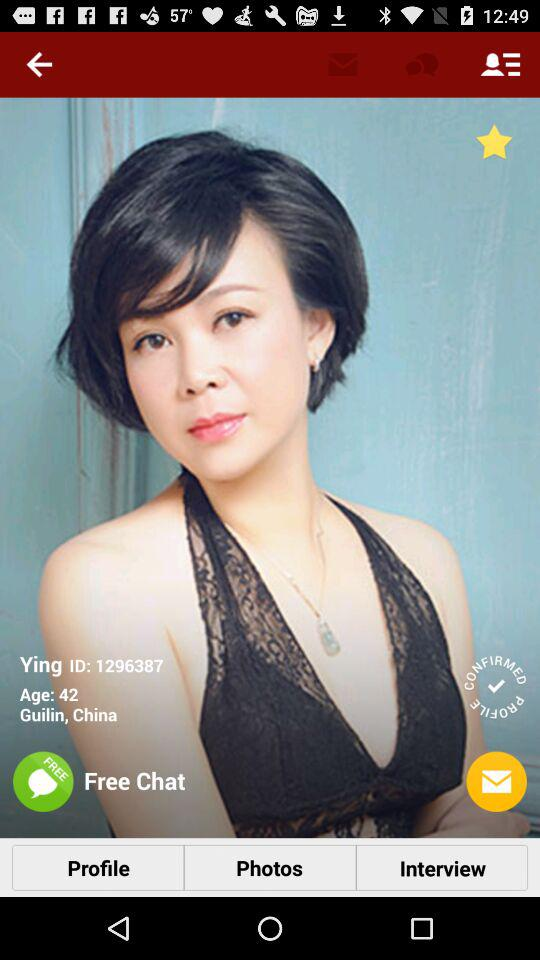What is the ID given for Ying? The ID is 1296387. 